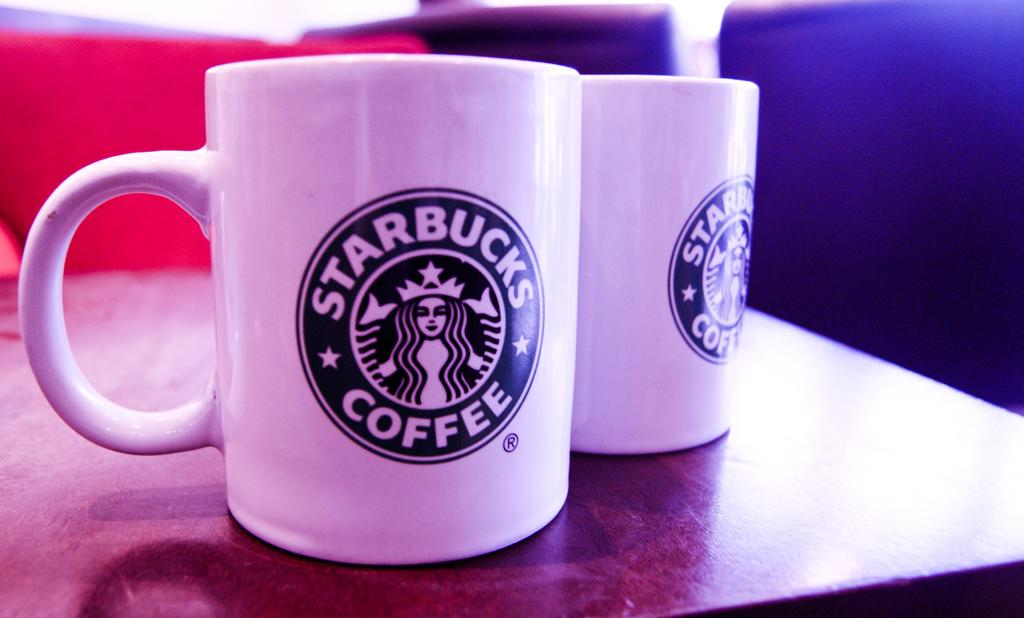Provide a one-sentence caption for the provided image. Two white coffee cups with the Starbucks logo on them. 